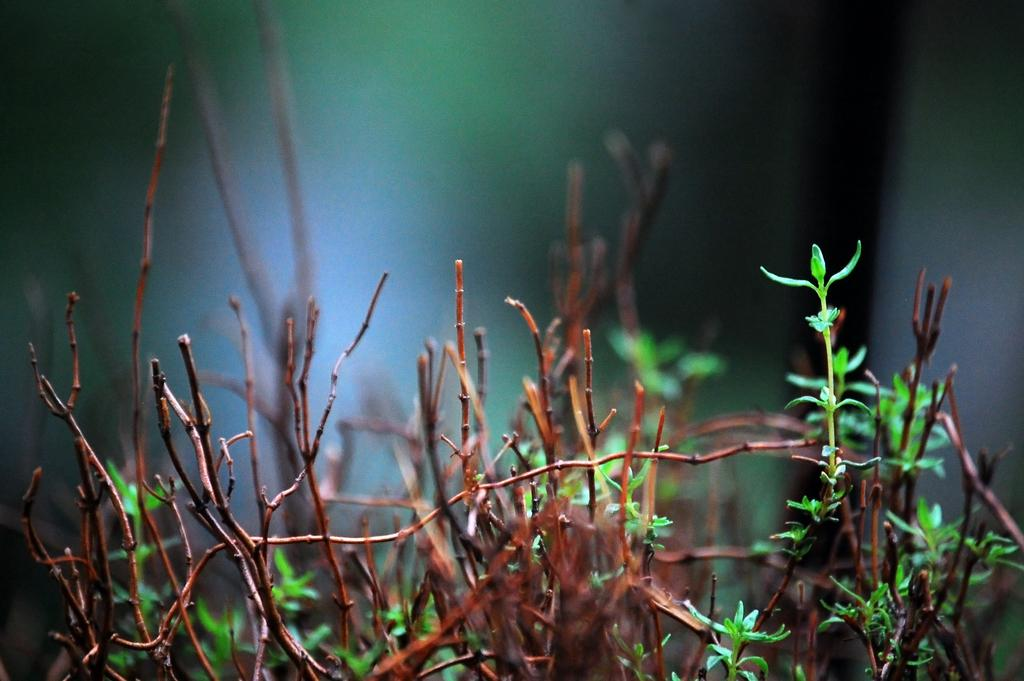What type of living organisms can be seen in the image? Plants can be seen in the image. What colors are present on the plants in the image? The plants have brown and green colors. How would you describe the background of the image? The background of the image is blurry. Is there a payment system visible in the image? There is no payment system present in the image; it features plants with brown and green colors and a blurry background. 